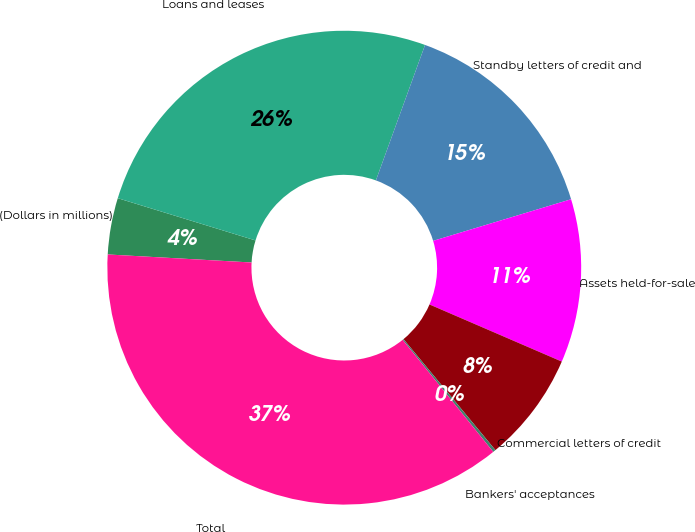Convert chart. <chart><loc_0><loc_0><loc_500><loc_500><pie_chart><fcel>(Dollars in millions)<fcel>Loans and leases<fcel>Standby letters of credit and<fcel>Assets held-for-sale<fcel>Commercial letters of credit<fcel>Bankers' acceptances<fcel>Total<nl><fcel>3.85%<fcel>25.8%<fcel>14.8%<fcel>11.15%<fcel>7.5%<fcel>0.19%<fcel>36.71%<nl></chart> 